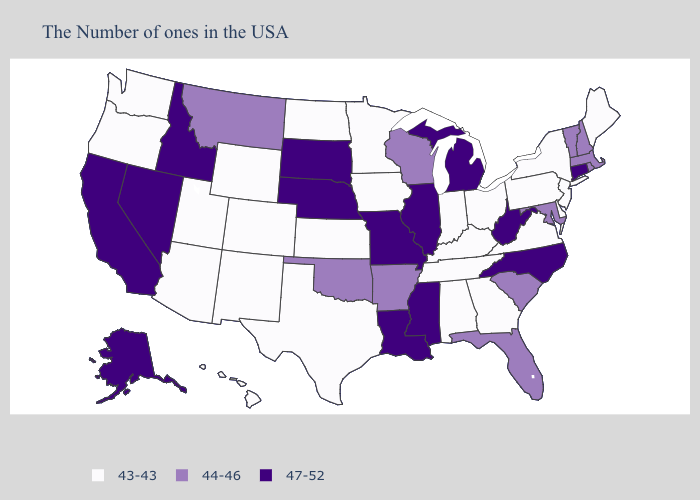What is the value of West Virginia?
Keep it brief. 47-52. What is the highest value in the MidWest ?
Quick response, please. 47-52. Does Louisiana have the highest value in the South?
Quick response, please. Yes. Among the states that border Maryland , which have the highest value?
Give a very brief answer. West Virginia. What is the value of Alaska?
Give a very brief answer. 47-52. What is the highest value in the USA?
Concise answer only. 47-52. What is the value of Kansas?
Short answer required. 43-43. Name the states that have a value in the range 47-52?
Be succinct. Connecticut, North Carolina, West Virginia, Michigan, Illinois, Mississippi, Louisiana, Missouri, Nebraska, South Dakota, Idaho, Nevada, California, Alaska. Does New York have the highest value in the USA?
Answer briefly. No. What is the value of Hawaii?
Quick response, please. 43-43. Which states have the highest value in the USA?
Be succinct. Connecticut, North Carolina, West Virginia, Michigan, Illinois, Mississippi, Louisiana, Missouri, Nebraska, South Dakota, Idaho, Nevada, California, Alaska. What is the lowest value in states that border Massachusetts?
Write a very short answer. 43-43. Does Tennessee have the same value as Indiana?
Keep it brief. Yes. Among the states that border Virginia , does West Virginia have the highest value?
Be succinct. Yes. Does Hawaii have the highest value in the USA?
Short answer required. No. 